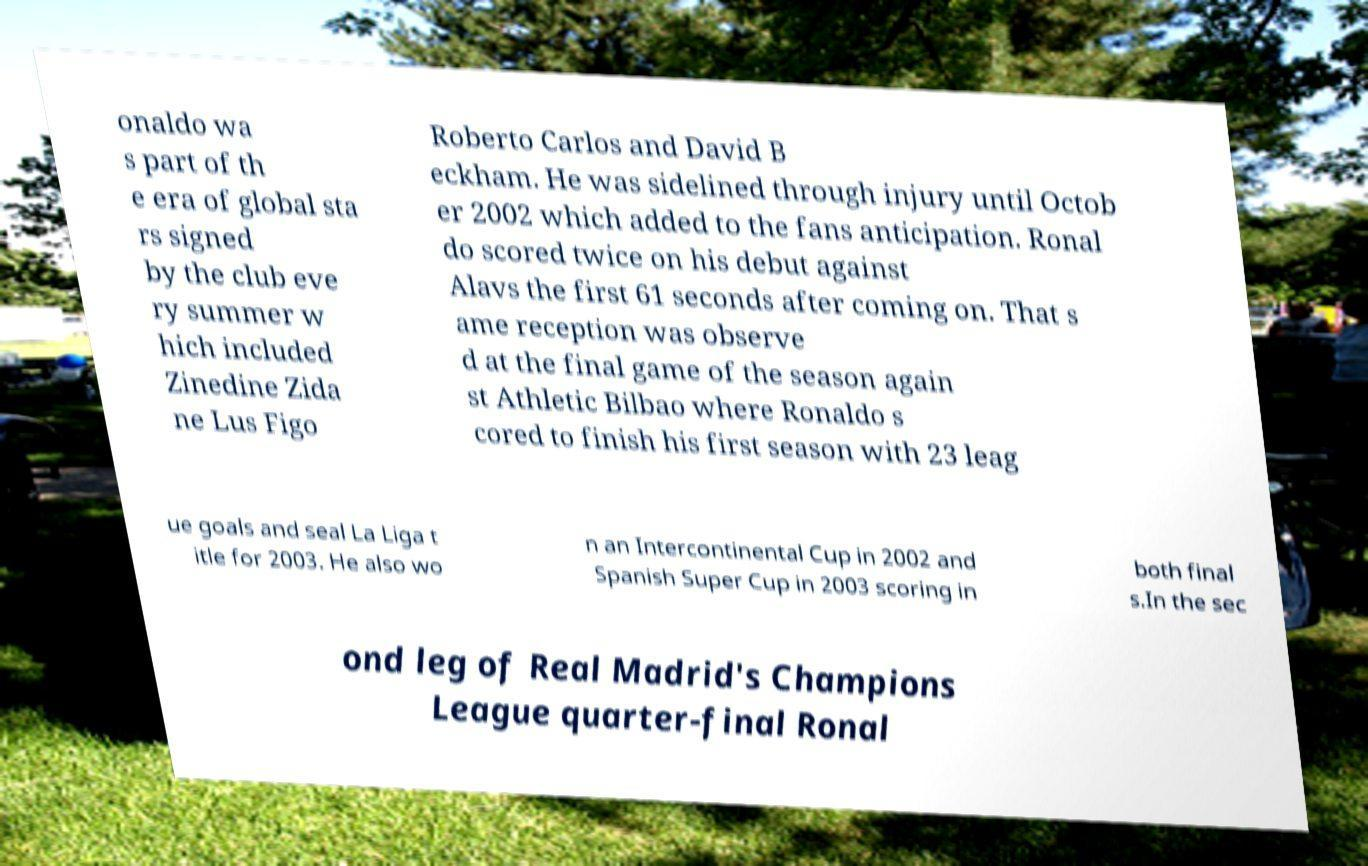Can you read and provide the text displayed in the image?This photo seems to have some interesting text. Can you extract and type it out for me? onaldo wa s part of th e era of global sta rs signed by the club eve ry summer w hich included Zinedine Zida ne Lus Figo Roberto Carlos and David B eckham. He was sidelined through injury until Octob er 2002 which added to the fans anticipation. Ronal do scored twice on his debut against Alavs the first 61 seconds after coming on. That s ame reception was observe d at the final game of the season again st Athletic Bilbao where Ronaldo s cored to finish his first season with 23 leag ue goals and seal La Liga t itle for 2003. He also wo n an Intercontinental Cup in 2002 and Spanish Super Cup in 2003 scoring in both final s.In the sec ond leg of Real Madrid's Champions League quarter-final Ronal 